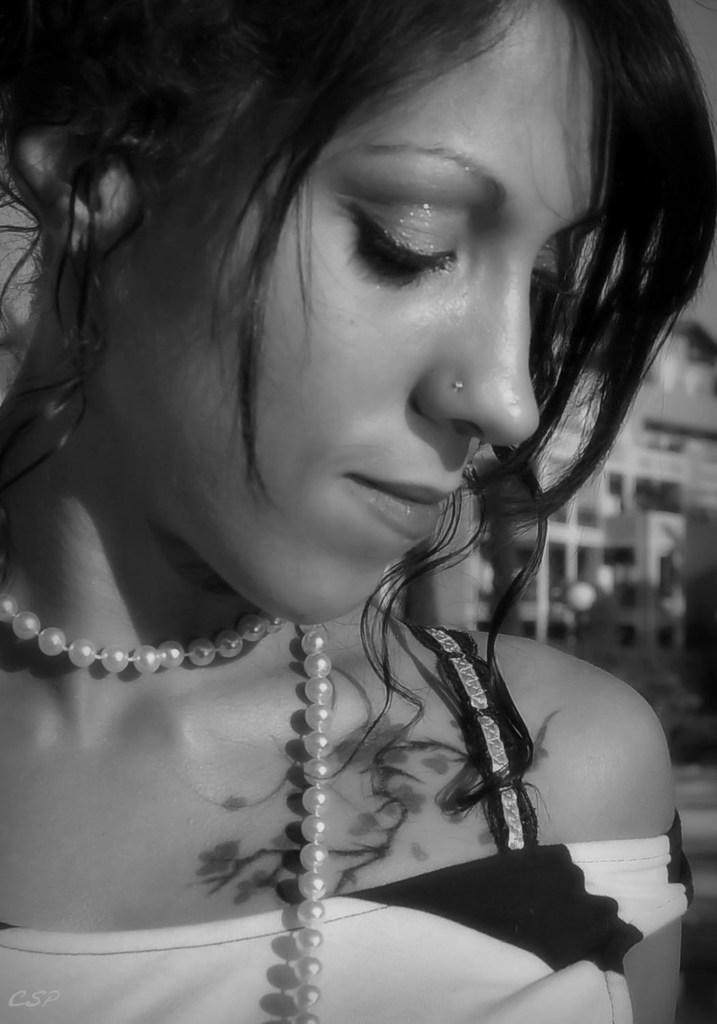What is the color scheme of the image? The image is black and white. Can you describe the main subject in the image? There is a woman in the foreground of the image. What type of treatment is the woman receiving in the image? There is no indication in the image that the woman is receiving any treatment. Can you see any locks in the image? There is no lock present in the image. What kind of pets are visible in the image? There are no pets visible in the image. 